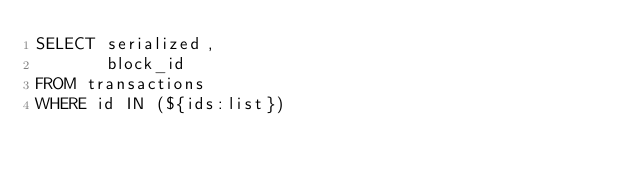Convert code to text. <code><loc_0><loc_0><loc_500><loc_500><_SQL_>SELECT serialized,
       block_id
FROM transactions
WHERE id IN (${ids:list})
</code> 